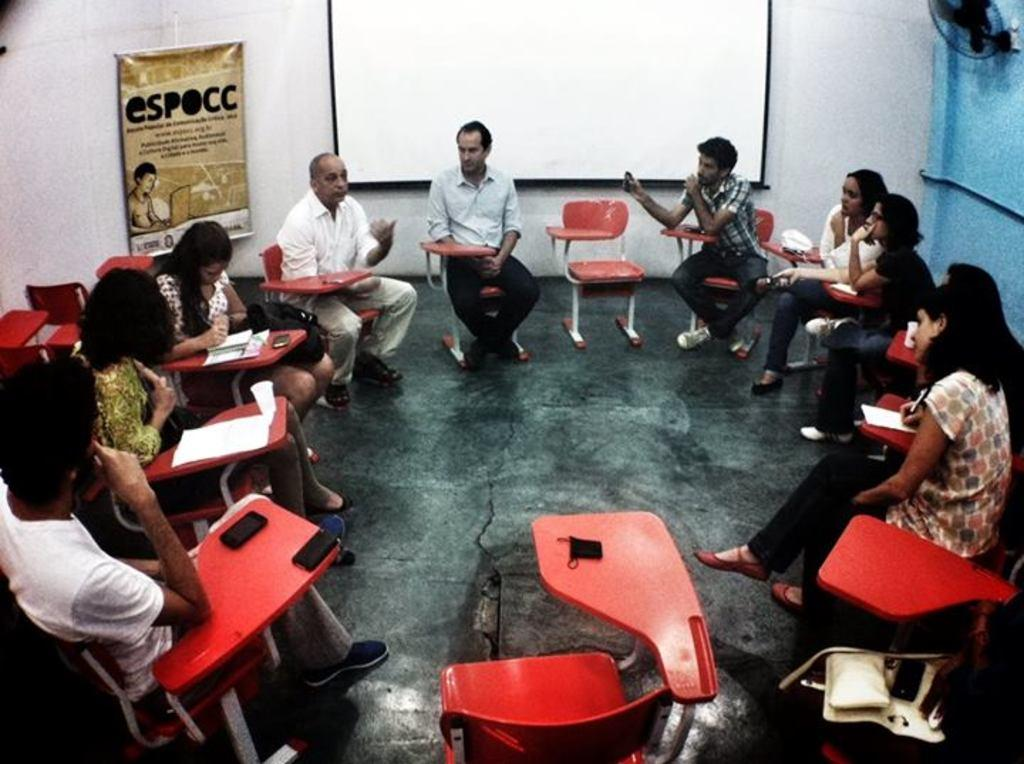What are the people in the image doing? There are persons sitting on chairs in the image. What can be seen under the people's feet? The image shows a floor. What is hanging or displayed in the image? There is a banner in the image. What is visible behind the people? There is a wall and a screen in the background of the image. What type of jar can be seen on the screen in the image? There is no jar visible on the screen in the image. What type of bells are ringing in the background of the image? There are no bells present in the image. 